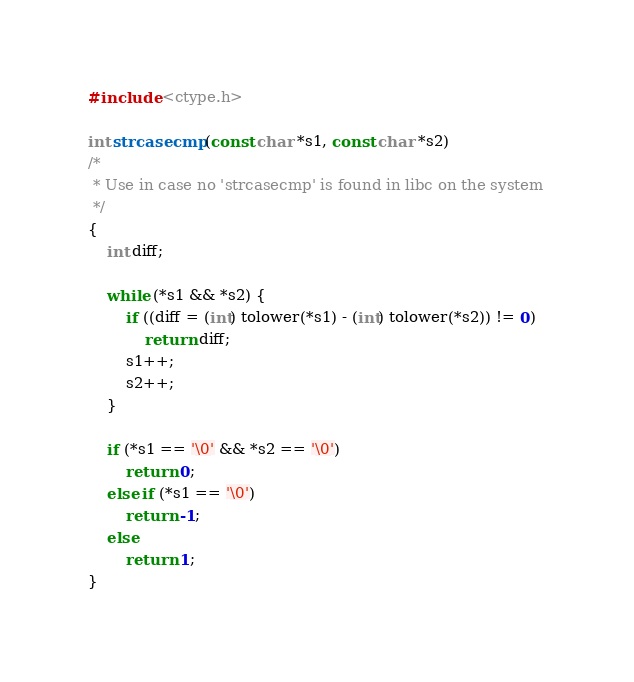Convert code to text. <code><loc_0><loc_0><loc_500><loc_500><_C_>#include <ctype.h>

int strcasecmp (const char *s1, const char *s2)
/* 
 * Use in case no 'strcasecmp' is found in libc on the system
 */
{
    int diff;

    while (*s1 && *s2) {
        if ((diff = (int) tolower(*s1) - (int) tolower(*s2)) != 0)  
            return diff;
        s1++;
        s2++;
    }

    if (*s1 == '\0' && *s2 == '\0') 
        return 0;
    else if (*s1 == '\0')
        return -1;
    else
        return 1;
}
</code> 